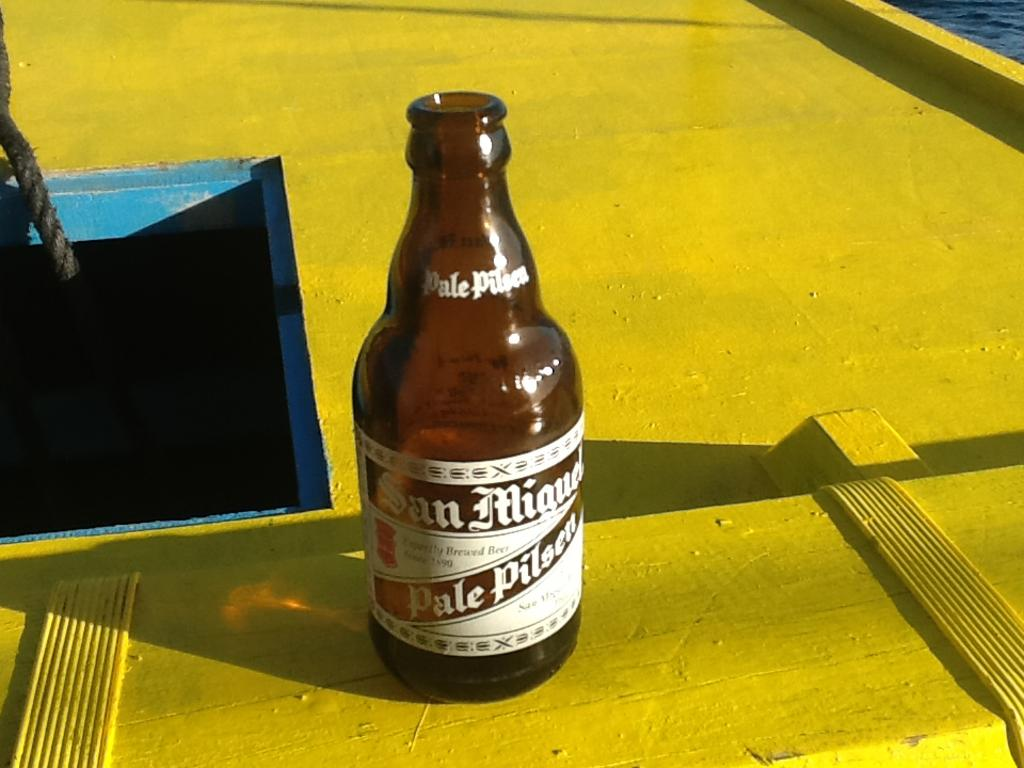<image>
Give a short and clear explanation of the subsequent image. A brown bottle of San Miguel Pale Pilser sits on wood painted yellow. 